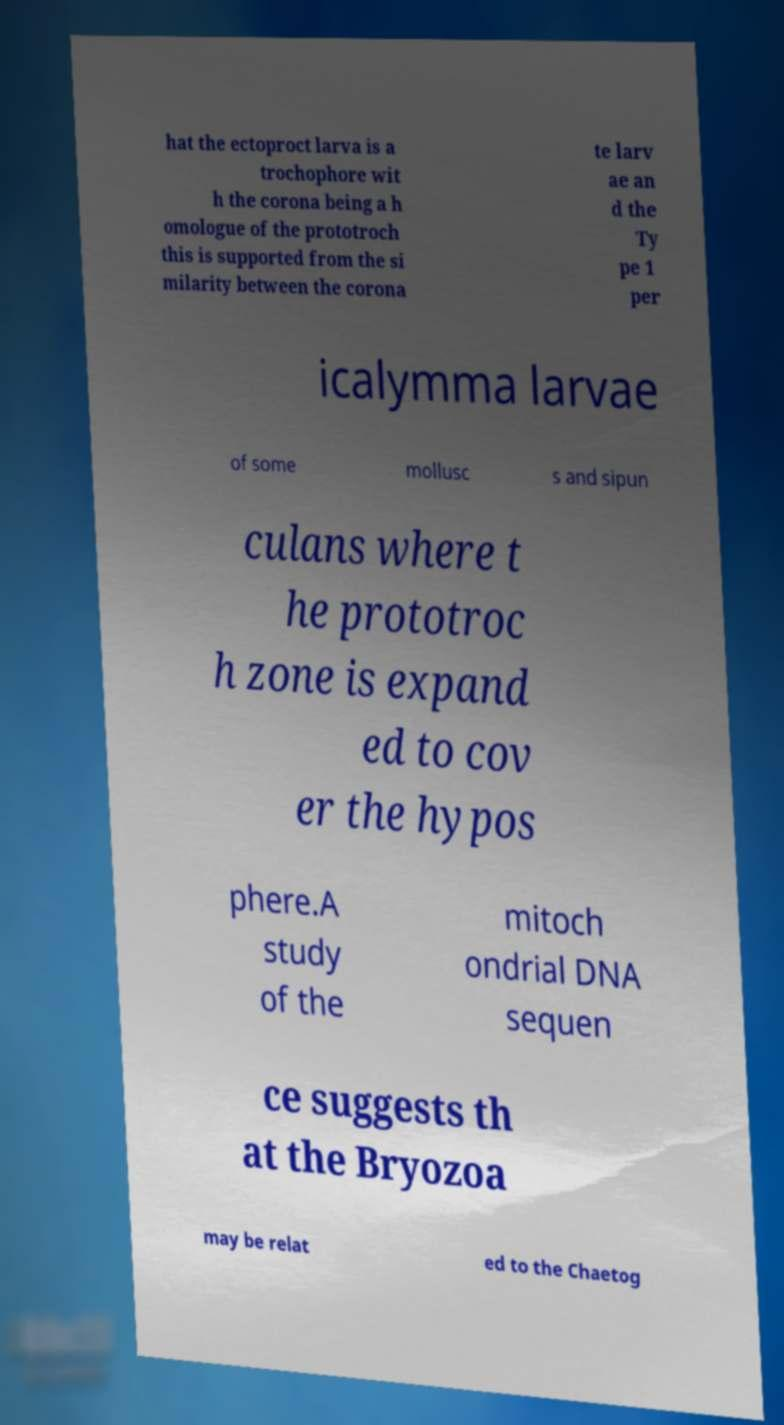I need the written content from this picture converted into text. Can you do that? hat the ectoproct larva is a trochophore wit h the corona being a h omologue of the prototroch this is supported from the si milarity between the corona te larv ae an d the Ty pe 1 per icalymma larvae of some mollusc s and sipun culans where t he prototroc h zone is expand ed to cov er the hypos phere.A study of the mitoch ondrial DNA sequen ce suggests th at the Bryozoa may be relat ed to the Chaetog 